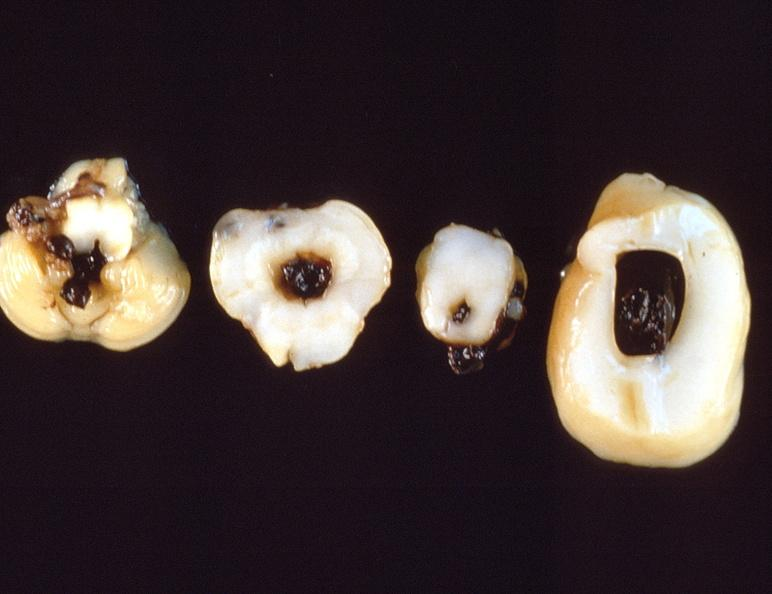what is present?
Answer the question using a single word or phrase. Nervous 